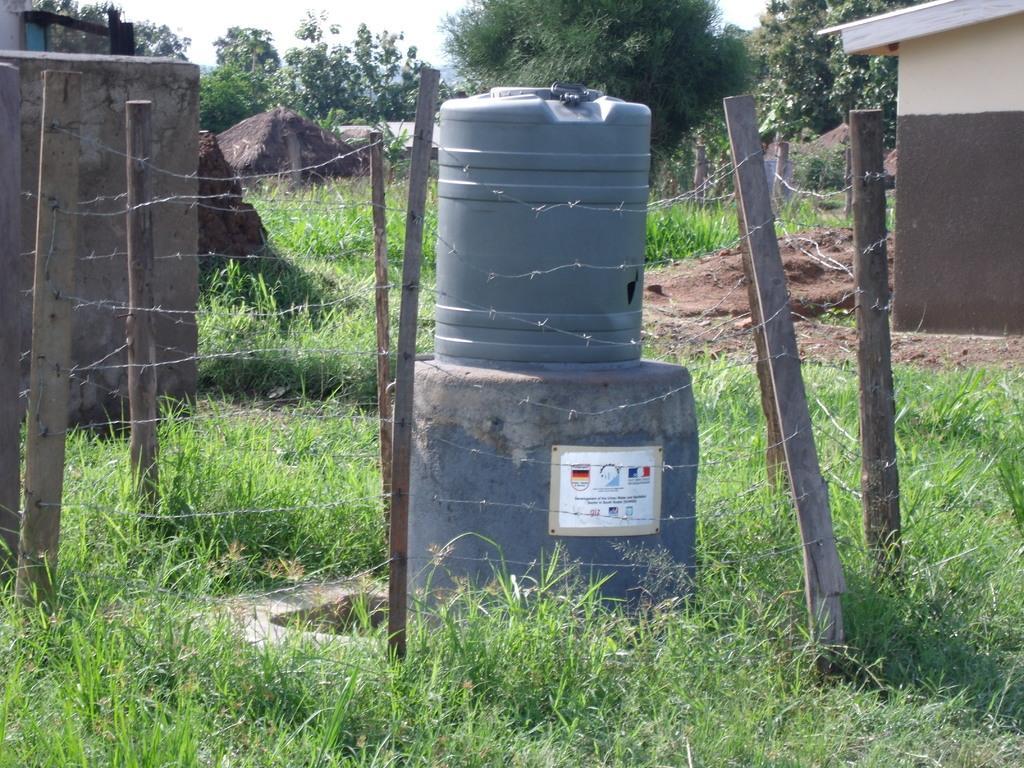In one or two sentences, can you explain what this image depicts? In this picture we can see some grass on the ground. We can see a water tank on a concrete slab. We can see a few things on an object visible on a concrete slab. There are wooden poles and wire fencing. We can see walls, trees and other objects. 